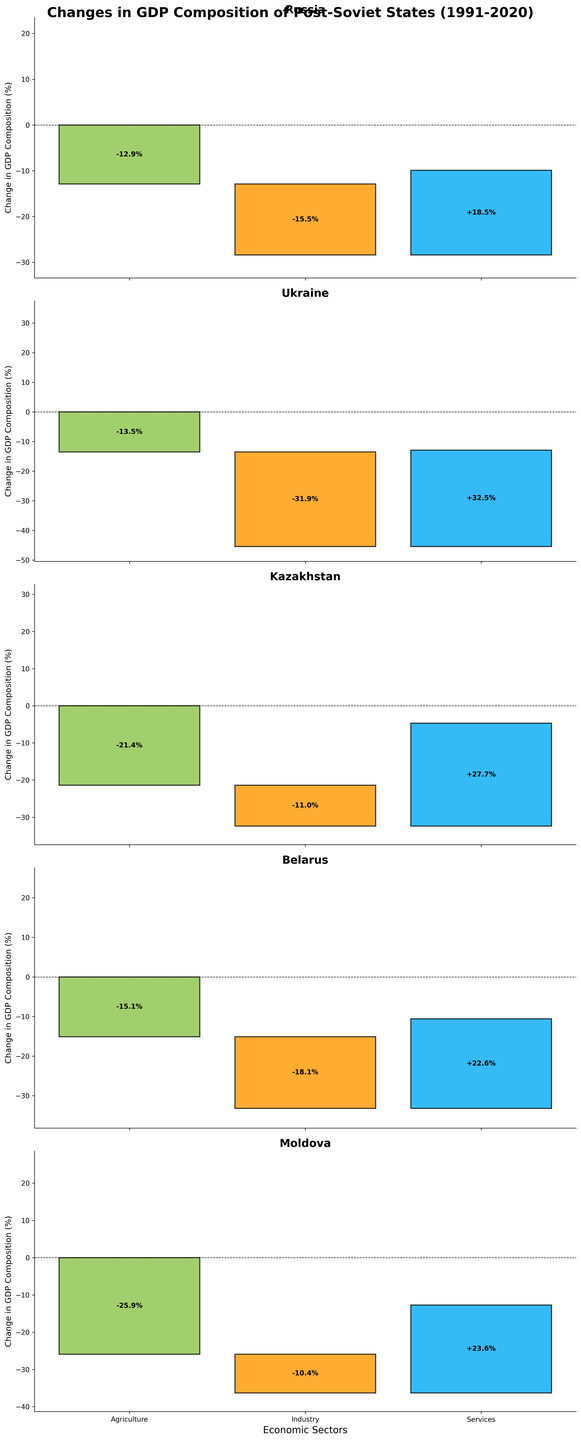What is the title of this figure? The title is usually located at the top of the figure and provides an overview of what the figure represents. In this case, the title is "Changes in GDP Composition of Post-Soviet States (1991-2020)."
Answer: Changes in GDP Composition of Post-Soviet States (1991-2020) For Russia, which sector had the largest decrease in GDP composition from 1991 to 2020? The chart shows the changes in GDP composition for different sectors. For Russia, the largest decrease is in the Industry sector with a change of -15.5%.
Answer: Industry How much did the Services sector increase in Kazakhstan's GDP composition from 1991 to 2020? Look at the bar for the Services sector in Kazakhstan and note the value of the increase, which is shown as +27.7%.
Answer: +27.7% Which country experienced the largest increase in the Services sector's GDP composition? Compare the increases in the Services sector across all countries. Ukraine has the largest increase with +32.5%.
Answer: Ukraine What's the smallest change in Industry sector GDP composition among the listed countries? Compare the bars representing the changes in the Industry sector for all countries. Moldova has the smallest decrease of -10.4%.
Answer: -10.4% Add up the changes in Agriculture and Industry sectors for Belarus. What is the cumulative change? Sum the changes in the Agriculture (-15.1%) and Industry (-18.1%) sectors for Belarus: -15.1 + (-18.1) = -33.2.
Answer: -33.2 Which country had the least negative change in the Agriculture sector's GDP composition? Compare the values of the negative changes in the Agriculture sector across all countries. Russia had the least negative change of -12.9%.
Answer: Russia Between Moldova and Ukraine, which country had a greater reduction in their Industry sector's GDP composition? Compare the reduction values in the Industry sector for Moldova (-10.4%) and Ukraine (-31.9%). Ukraine had a greater reduction.
Answer: Ukraine 